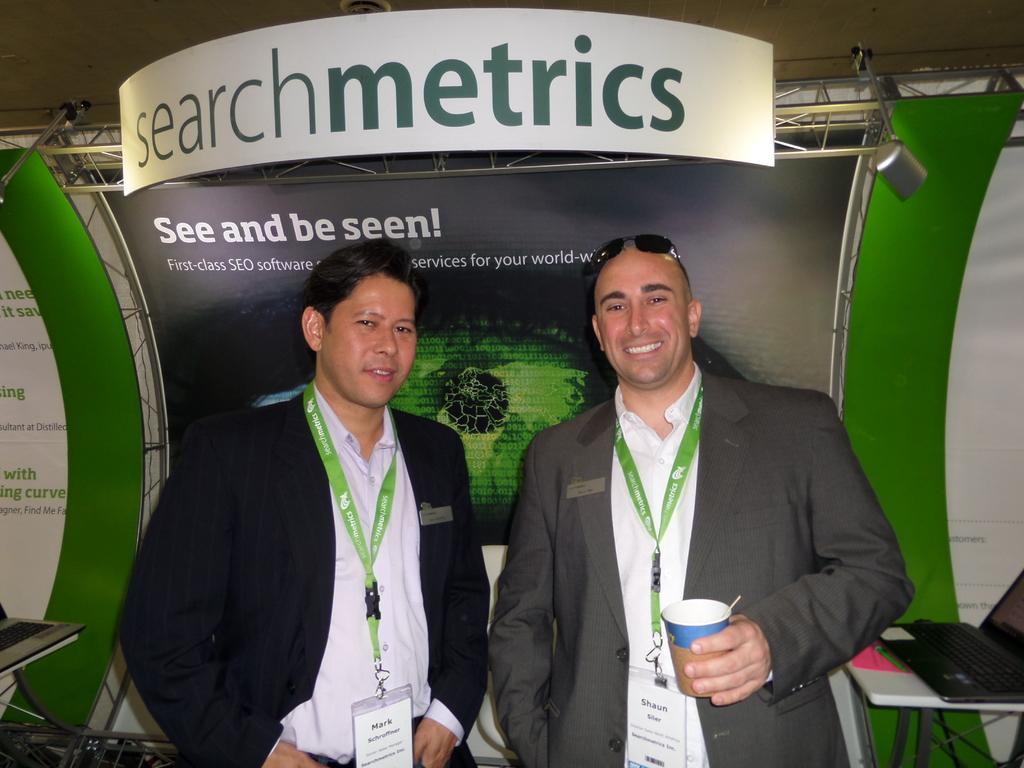Please provide a concise description of this image. The man in the left side of the picture wearing a white shirt and black blazer is holding a cup in his hand and he is smiling. Beside him, the man in black blazer who is wearing ID card is standing and he is smiling. Behind them, we see a table on which laptop is placed. Behind them, we see a board in black, white and green color with some text written on it. At the top of the picture, we see a white color board with text written as "SEARCH METRICS". 